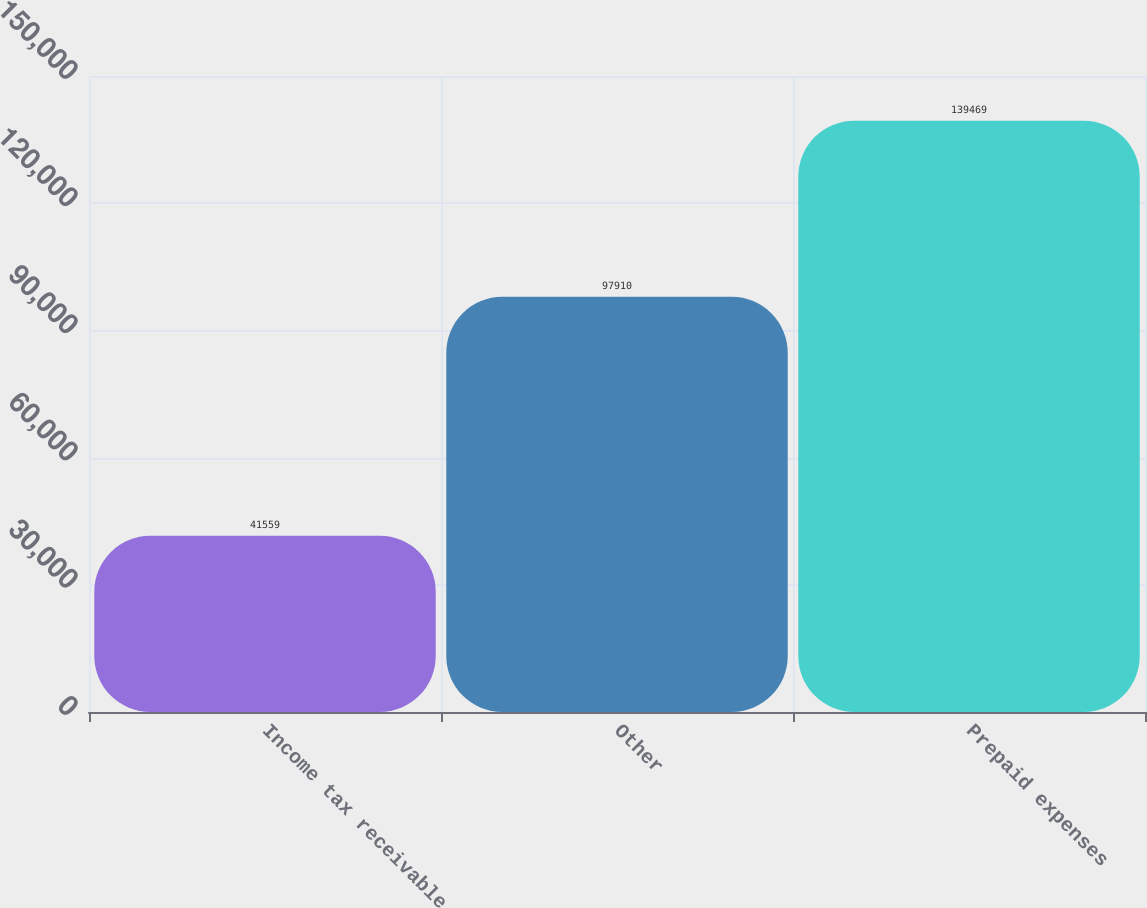<chart> <loc_0><loc_0><loc_500><loc_500><bar_chart><fcel>Income tax receivable<fcel>Other<fcel>Prepaid expenses<nl><fcel>41559<fcel>97910<fcel>139469<nl></chart> 